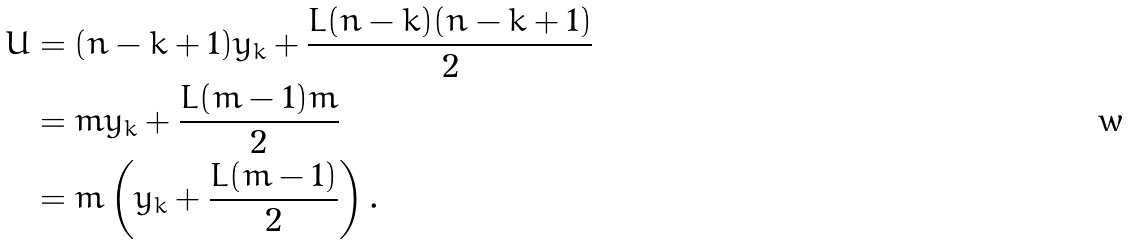<formula> <loc_0><loc_0><loc_500><loc_500>U & = ( n - k + 1 ) y _ { k } + \frac { L ( n - k ) ( n - k + 1 ) } { 2 } \\ & = m y _ { k } + \frac { L ( m - 1 ) m } { 2 } \\ & = m \left ( y _ { k } + \frac { L ( m - 1 ) } { 2 } \right ) .</formula> 